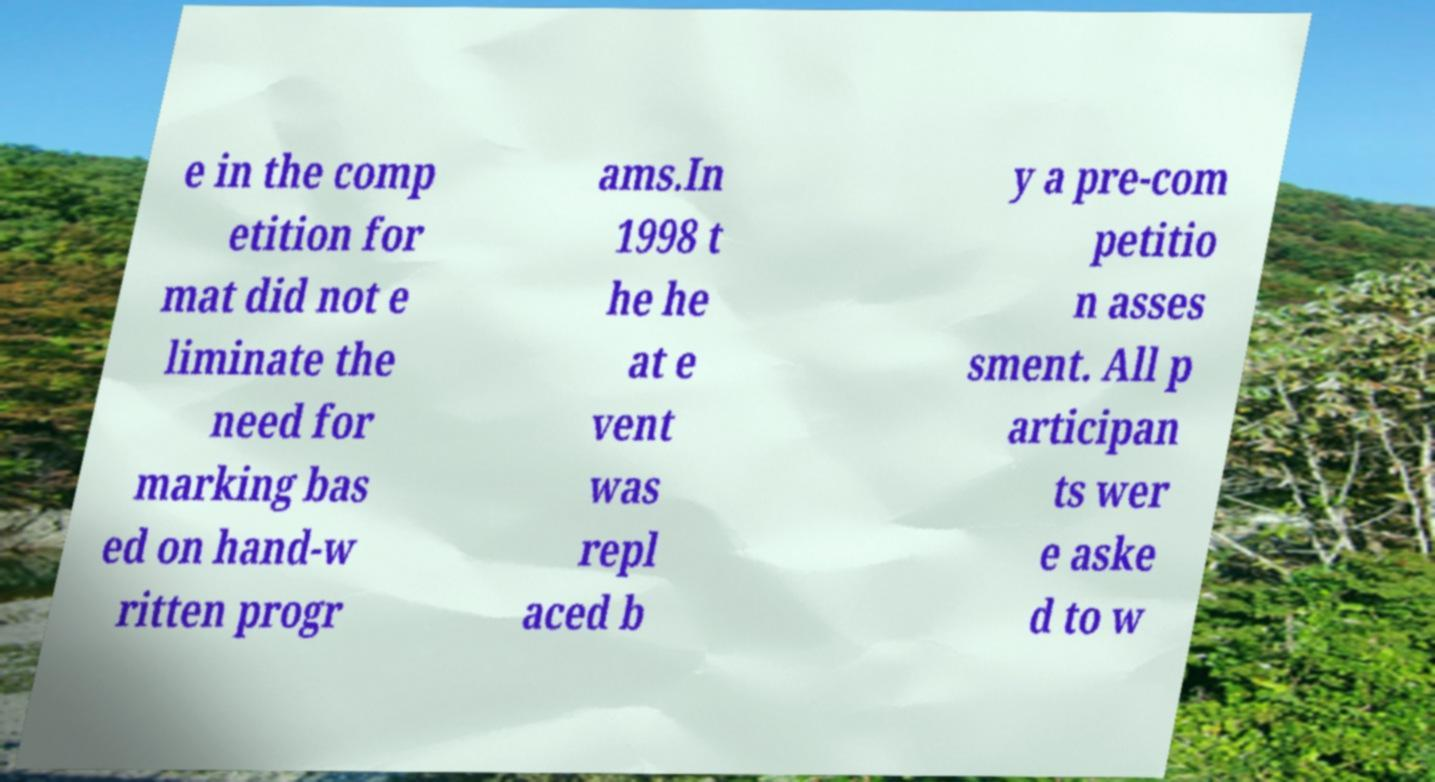Please read and relay the text visible in this image. What does it say? e in the comp etition for mat did not e liminate the need for marking bas ed on hand-w ritten progr ams.In 1998 t he he at e vent was repl aced b y a pre-com petitio n asses sment. All p articipan ts wer e aske d to w 